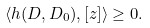<formula> <loc_0><loc_0><loc_500><loc_500>\langle h ( D , D _ { 0 } ) , [ z ] \rangle \geq 0 .</formula> 